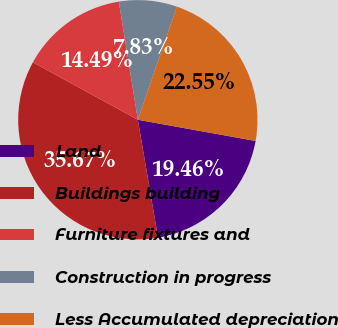<chart> <loc_0><loc_0><loc_500><loc_500><pie_chart><fcel>Land<fcel>Buildings building<fcel>Furniture fixtures and<fcel>Construction in progress<fcel>Less Accumulated depreciation<nl><fcel>19.46%<fcel>35.67%<fcel>14.49%<fcel>7.83%<fcel>22.55%<nl></chart> 